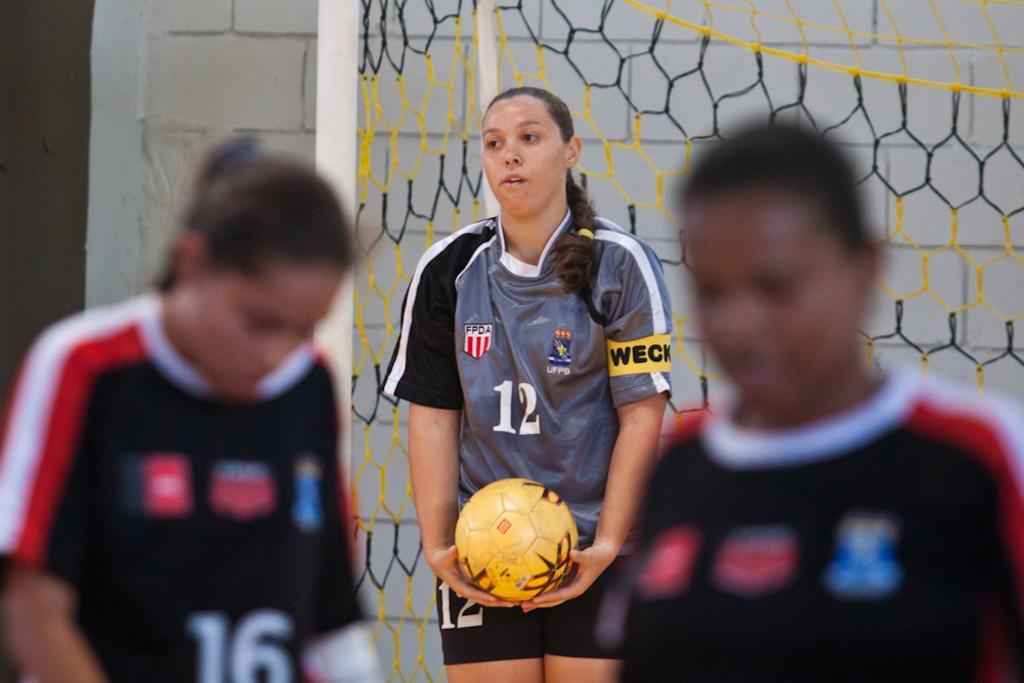Could you give a brief overview of what you see in this image? This picture shows few people playing football and we see a net on their back 